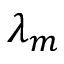Convert formula to latex. <formula><loc_0><loc_0><loc_500><loc_500>\lambda _ { m }</formula> 